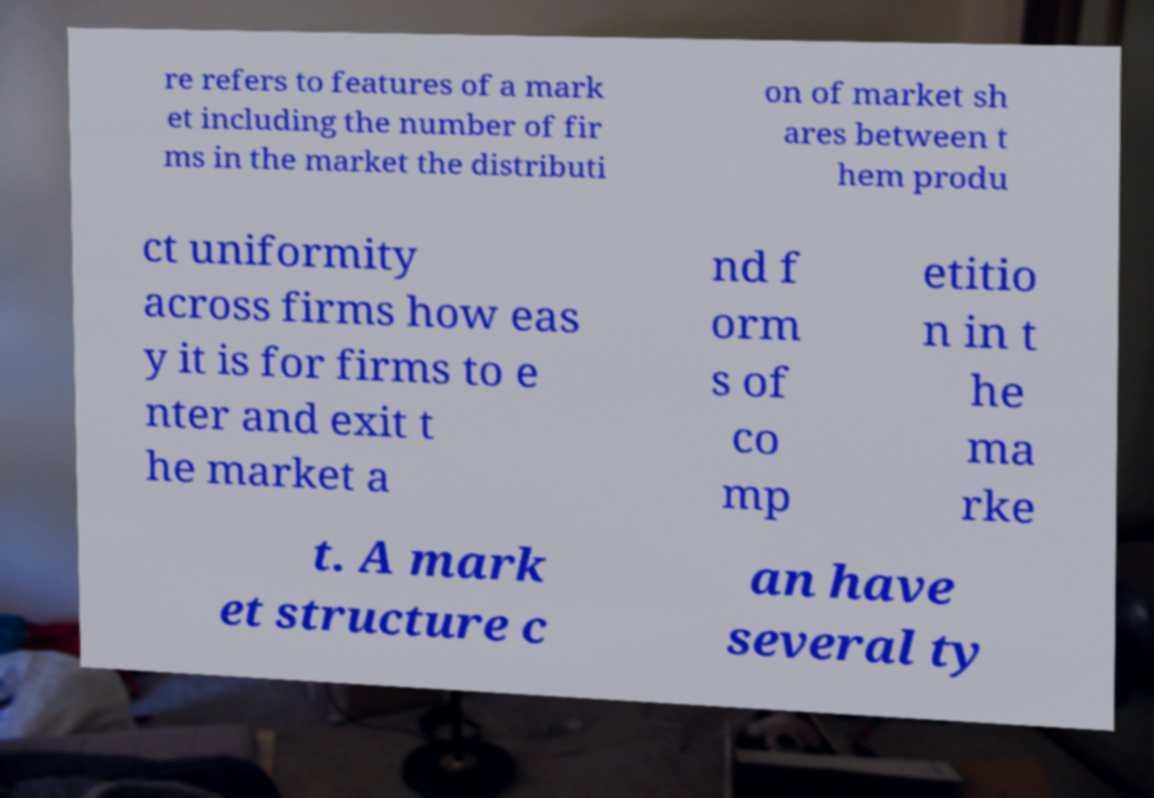I need the written content from this picture converted into text. Can you do that? re refers to features of a mark et including the number of fir ms in the market the distributi on of market sh ares between t hem produ ct uniformity across firms how eas y it is for firms to e nter and exit t he market a nd f orm s of co mp etitio n in t he ma rke t. A mark et structure c an have several ty 